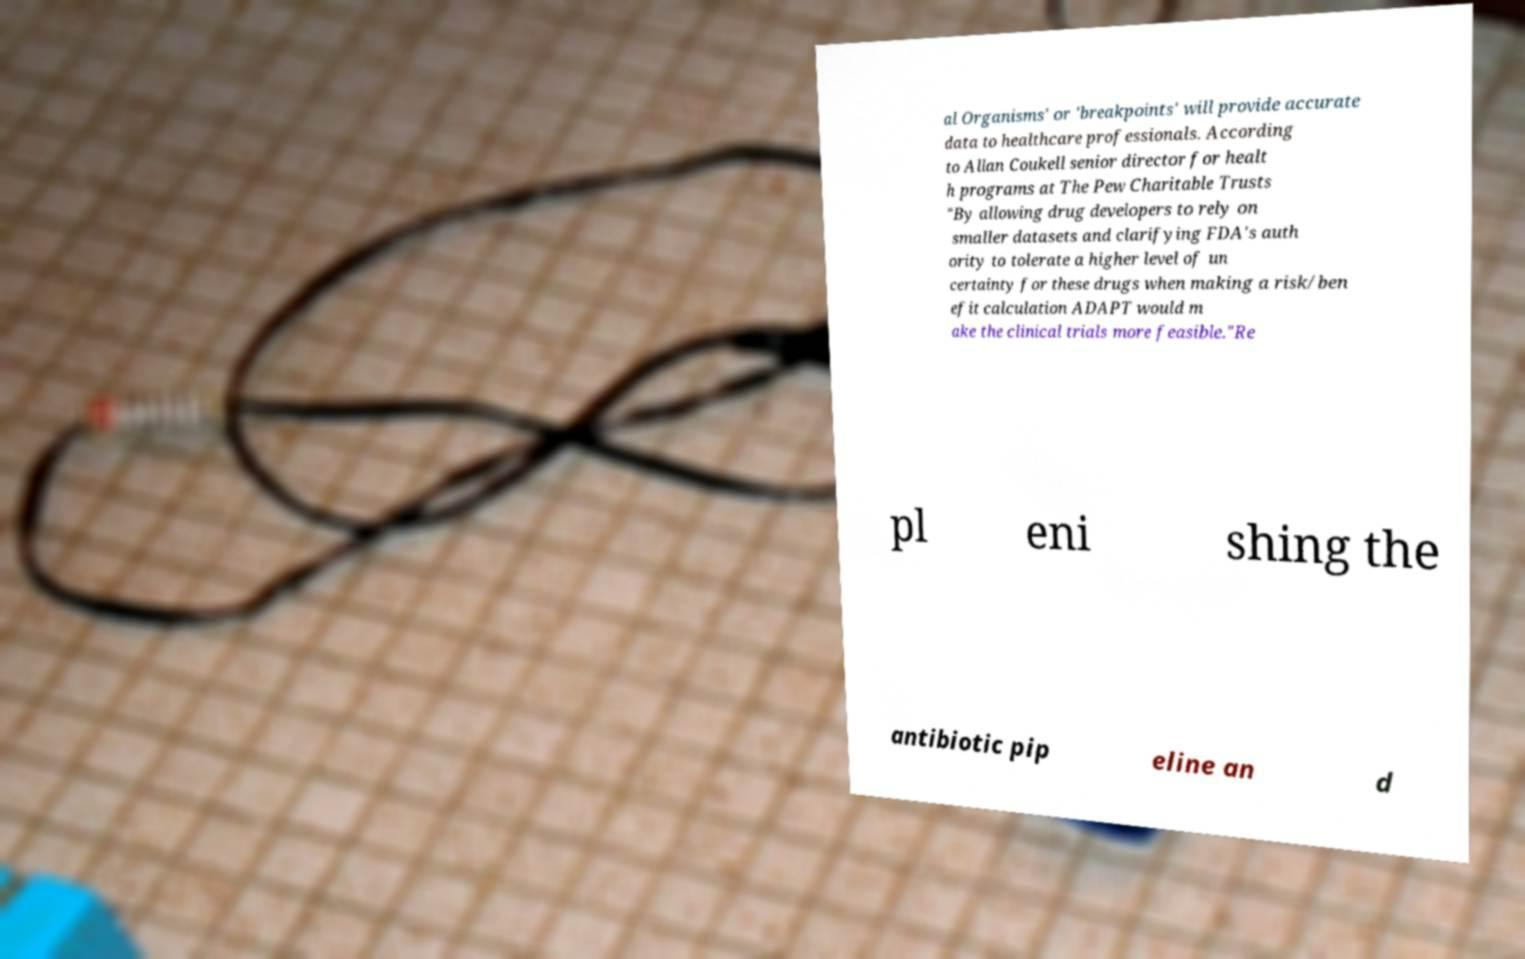What messages or text are displayed in this image? I need them in a readable, typed format. al Organisms' or 'breakpoints' will provide accurate data to healthcare professionals. According to Allan Coukell senior director for healt h programs at The Pew Charitable Trusts "By allowing drug developers to rely on smaller datasets and clarifying FDA's auth ority to tolerate a higher level of un certainty for these drugs when making a risk/ben efit calculation ADAPT would m ake the clinical trials more feasible."Re pl eni shing the antibiotic pip eline an d 